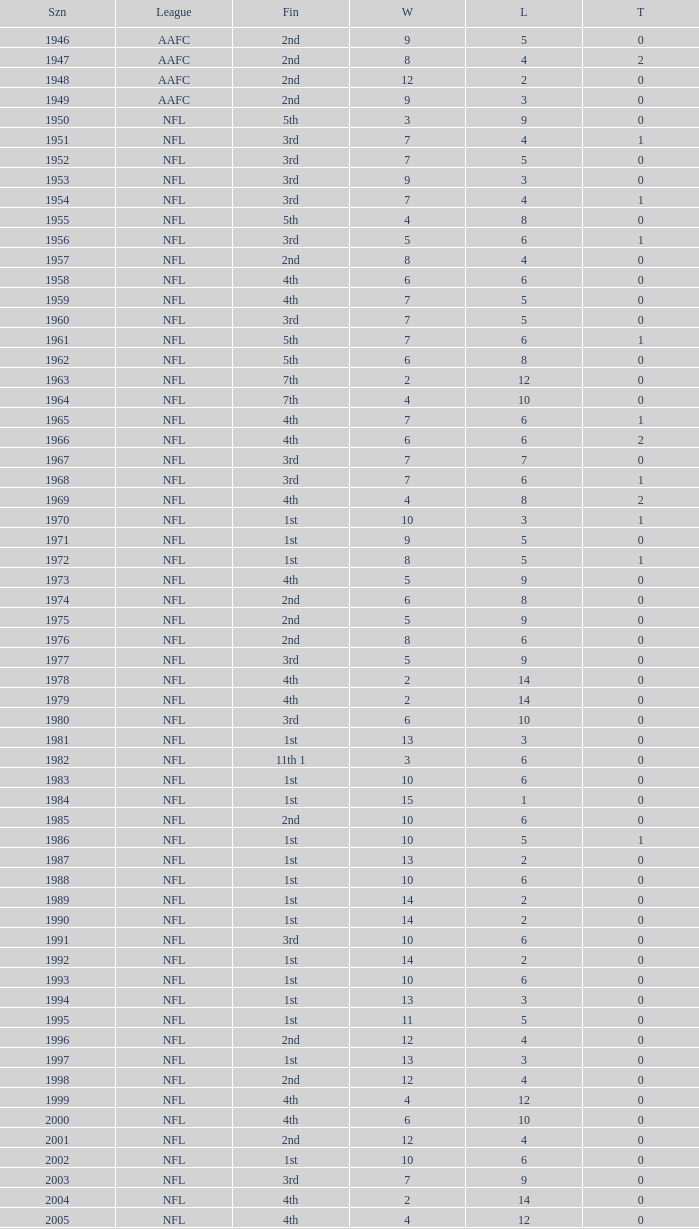What is the number of losses when the ties are lesser than 0? 0.0. 